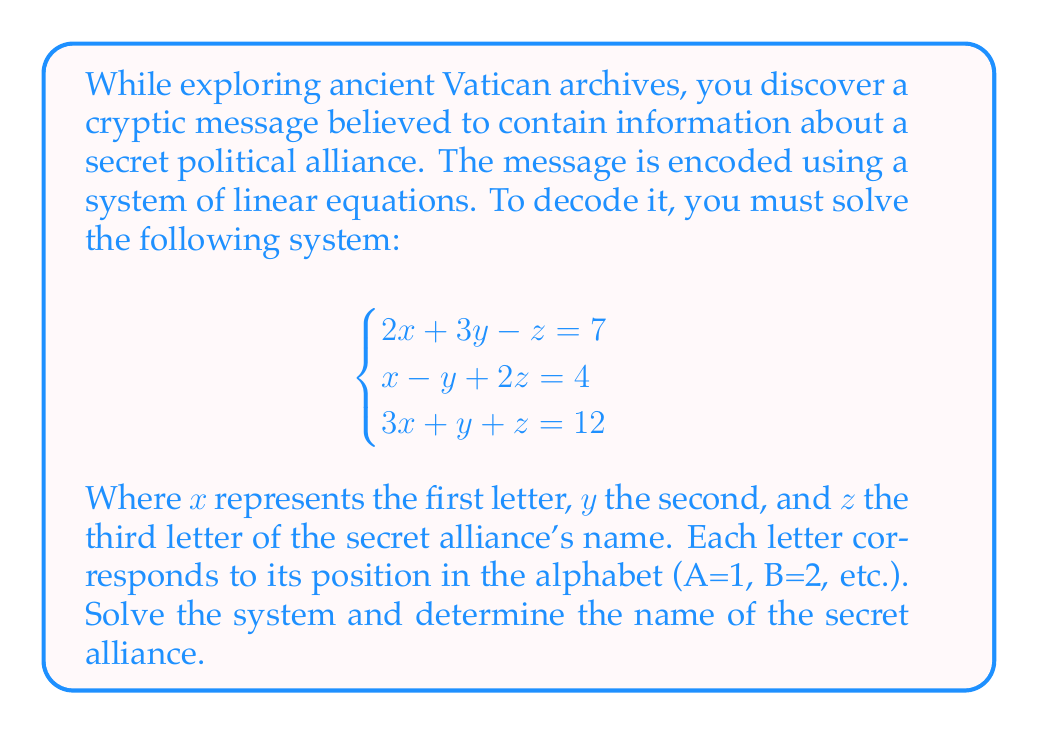Show me your answer to this math problem. To solve this system of linear equations, we'll use the Gaussian elimination method:

1) First, write the augmented matrix:

$$\begin{bmatrix}
2 & 3 & -1 & 7 \\
1 & -1 & 2 & 4 \\
3 & 1 & 1 & 12
\end{bmatrix}$$

2) Multiply the first row by -1 and add it to the third row:

$$\begin{bmatrix}
2 & 3 & -1 & 7 \\
1 & -1 & 2 & 4 \\
1 & -2 & 2 & 5
\end{bmatrix}$$

3) Subtract the second row from the third row:

$$\begin{bmatrix}
2 & 3 & -1 & 7 \\
1 & -1 & 2 & 4 \\
0 & -1 & 0 & 1
\end{bmatrix}$$

4) Multiply the third row by -1:

$$\begin{bmatrix}
2 & 3 & -1 & 7 \\
1 & -1 & 2 & 4 \\
0 & 1 & 0 & -1
\end{bmatrix}$$

5) Add the third row to the second row:

$$\begin{bmatrix}
2 & 3 & -1 & 7 \\
1 & 0 & 2 & 3 \\
0 & 1 & 0 & -1
\end{bmatrix}$$

6) Multiply the second row by -2 and add it to the first row:

$$\begin{bmatrix}
0 & 3 & -5 & 1 \\
1 & 0 & 2 & 3 \\
0 & 1 & 0 & -1
\end{bmatrix}$$

7) Divide the first row by 3:

$$\begin{bmatrix}
0 & 1 & -\frac{5}{3} & \frac{1}{3} \\
1 & 0 & 2 & 3 \\
0 & 1 & 0 & -1
\end{bmatrix}$$

8) Add the third row to the first row:

$$\begin{bmatrix}
0 & 2 & -\frac{5}{3} & -\frac{2}{3} \\
1 & 0 & 2 & 3 \\
0 & 1 & 0 & -1
\end{bmatrix}$$

9) Divide the first row by 2:

$$\begin{bmatrix}
0 & 1 & -\frac{5}{6} & -\frac{1}{3} \\
1 & 0 & 2 & 3 \\
0 & 1 & 0 & -1
\end{bmatrix}$$

10) Add $\frac{5}{6}$ times the third row to the first row:

$$\begin{bmatrix}
0 & 1 & 0 & -1 \\
1 & 0 & 2 & 3 \\
0 & 1 & 0 & -1
\end{bmatrix}$$

11) Subtract 2 times the first row from the second row:

$$\begin{bmatrix}
0 & 1 & 0 & -1 \\
1 & 0 & 0 & 5 \\
0 & 1 & 0 & -1
\end{bmatrix}$$

The solution is:
$x = 5$, $y = -1$, $z = 1$

Converting these to letters (remembering that negative numbers wrap around from Z):
$x = 5 \rightarrow E$
$y = -1 \rightarrow Z$
$z = 1 \rightarrow A$

Therefore, the secret alliance's name is EZA.
Answer: The secret alliance's name is EZA. 